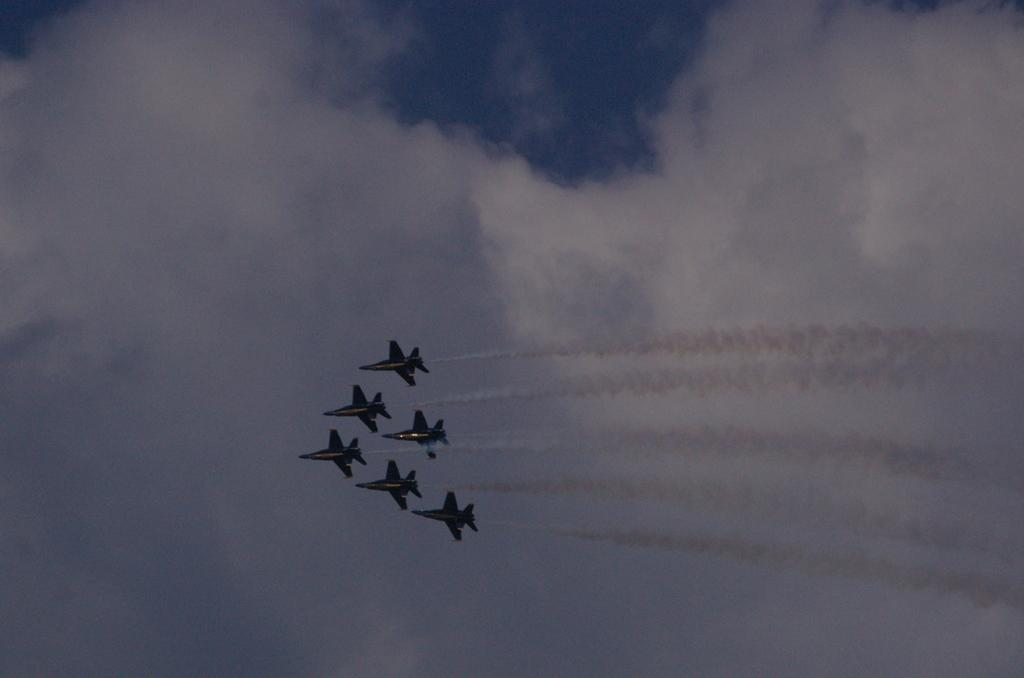How many planes can be seen in the image? There are six planes in the image. What are the planes doing in the image? The planes are flying in the air. Is there any visible indication of the planes' activity in the image? Yes, smoke is releasing from the planes. What can be seen in the background of the image? There is a sky visible in the background of the image. What is the condition of the sky in the image? Clouds are present in the sky. Can you see any people on the boats in the image? There are no boats present in the image; it features six planes flying in the air. What type of approval is required for the planes to fly in the image? The image does not provide information about any required approvals for the planes to fly. 